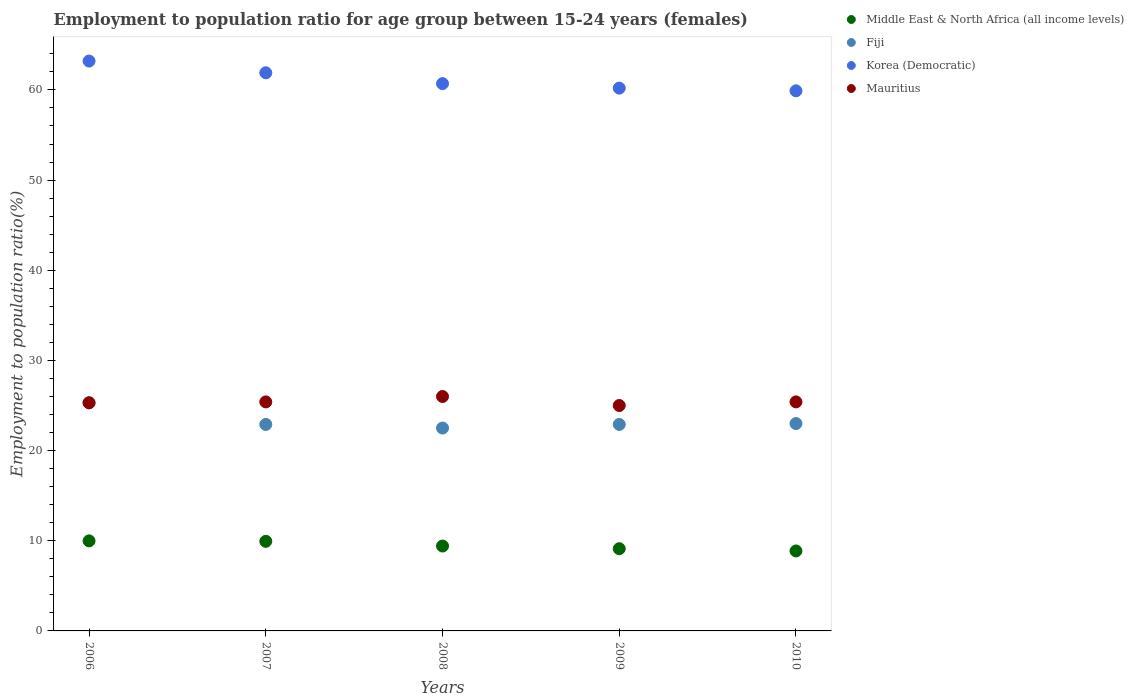How many different coloured dotlines are there?
Provide a succinct answer. 4. What is the employment to population ratio in Korea (Democratic) in 2009?
Provide a short and direct response. 60.2. Across all years, what is the maximum employment to population ratio in Middle East & North Africa (all income levels)?
Offer a terse response. 9.99. Across all years, what is the minimum employment to population ratio in Middle East & North Africa (all income levels)?
Keep it short and to the point. 8.87. In which year was the employment to population ratio in Mauritius maximum?
Your answer should be very brief. 2008. In which year was the employment to population ratio in Fiji minimum?
Provide a short and direct response. 2008. What is the total employment to population ratio in Fiji in the graph?
Keep it short and to the point. 116.6. What is the difference between the employment to population ratio in Mauritius in 2007 and that in 2008?
Ensure brevity in your answer.  -0.6. What is the difference between the employment to population ratio in Fiji in 2006 and the employment to population ratio in Mauritius in 2009?
Make the answer very short. 0.3. What is the average employment to population ratio in Korea (Democratic) per year?
Your answer should be very brief. 61.18. In the year 2009, what is the difference between the employment to population ratio in Middle East & North Africa (all income levels) and employment to population ratio in Korea (Democratic)?
Offer a terse response. -51.08. In how many years, is the employment to population ratio in Middle East & North Africa (all income levels) greater than 20 %?
Offer a terse response. 0. What is the ratio of the employment to population ratio in Middle East & North Africa (all income levels) in 2006 to that in 2007?
Offer a terse response. 1.01. What is the difference between the highest and the second highest employment to population ratio in Korea (Democratic)?
Keep it short and to the point. 1.3. What is the difference between the highest and the lowest employment to population ratio in Korea (Democratic)?
Your response must be concise. 3.3. Is it the case that in every year, the sum of the employment to population ratio in Mauritius and employment to population ratio in Middle East & North Africa (all income levels)  is greater than the employment to population ratio in Korea (Democratic)?
Offer a terse response. No. How many dotlines are there?
Your answer should be very brief. 4. How many years are there in the graph?
Offer a very short reply. 5. Does the graph contain any zero values?
Your answer should be very brief. No. Does the graph contain grids?
Provide a succinct answer. No. How many legend labels are there?
Offer a very short reply. 4. How are the legend labels stacked?
Provide a short and direct response. Vertical. What is the title of the graph?
Ensure brevity in your answer.  Employment to population ratio for age group between 15-24 years (females). Does "Zimbabwe" appear as one of the legend labels in the graph?
Provide a succinct answer. No. What is the label or title of the X-axis?
Your response must be concise. Years. What is the label or title of the Y-axis?
Make the answer very short. Employment to population ratio(%). What is the Employment to population ratio(%) in Middle East & North Africa (all income levels) in 2006?
Provide a short and direct response. 9.99. What is the Employment to population ratio(%) of Fiji in 2006?
Provide a succinct answer. 25.3. What is the Employment to population ratio(%) of Korea (Democratic) in 2006?
Provide a short and direct response. 63.2. What is the Employment to population ratio(%) in Mauritius in 2006?
Your response must be concise. 25.3. What is the Employment to population ratio(%) in Middle East & North Africa (all income levels) in 2007?
Keep it short and to the point. 9.94. What is the Employment to population ratio(%) in Fiji in 2007?
Your answer should be very brief. 22.9. What is the Employment to population ratio(%) of Korea (Democratic) in 2007?
Your answer should be compact. 61.9. What is the Employment to population ratio(%) of Mauritius in 2007?
Give a very brief answer. 25.4. What is the Employment to population ratio(%) of Middle East & North Africa (all income levels) in 2008?
Make the answer very short. 9.41. What is the Employment to population ratio(%) of Korea (Democratic) in 2008?
Keep it short and to the point. 60.7. What is the Employment to population ratio(%) of Mauritius in 2008?
Provide a succinct answer. 26. What is the Employment to population ratio(%) in Middle East & North Africa (all income levels) in 2009?
Make the answer very short. 9.12. What is the Employment to population ratio(%) in Fiji in 2009?
Your answer should be very brief. 22.9. What is the Employment to population ratio(%) of Korea (Democratic) in 2009?
Provide a short and direct response. 60.2. What is the Employment to population ratio(%) in Middle East & North Africa (all income levels) in 2010?
Make the answer very short. 8.87. What is the Employment to population ratio(%) in Fiji in 2010?
Give a very brief answer. 23. What is the Employment to population ratio(%) in Korea (Democratic) in 2010?
Your response must be concise. 59.9. What is the Employment to population ratio(%) in Mauritius in 2010?
Your response must be concise. 25.4. Across all years, what is the maximum Employment to population ratio(%) of Middle East & North Africa (all income levels)?
Give a very brief answer. 9.99. Across all years, what is the maximum Employment to population ratio(%) of Fiji?
Your answer should be compact. 25.3. Across all years, what is the maximum Employment to population ratio(%) of Korea (Democratic)?
Keep it short and to the point. 63.2. Across all years, what is the minimum Employment to population ratio(%) of Middle East & North Africa (all income levels)?
Offer a very short reply. 8.87. Across all years, what is the minimum Employment to population ratio(%) in Korea (Democratic)?
Make the answer very short. 59.9. Across all years, what is the minimum Employment to population ratio(%) of Mauritius?
Ensure brevity in your answer.  25. What is the total Employment to population ratio(%) of Middle East & North Africa (all income levels) in the graph?
Your response must be concise. 47.33. What is the total Employment to population ratio(%) of Fiji in the graph?
Provide a succinct answer. 116.6. What is the total Employment to population ratio(%) in Korea (Democratic) in the graph?
Provide a succinct answer. 305.9. What is the total Employment to population ratio(%) of Mauritius in the graph?
Offer a terse response. 127.1. What is the difference between the Employment to population ratio(%) in Middle East & North Africa (all income levels) in 2006 and that in 2007?
Provide a succinct answer. 0.05. What is the difference between the Employment to population ratio(%) of Middle East & North Africa (all income levels) in 2006 and that in 2008?
Your answer should be very brief. 0.57. What is the difference between the Employment to population ratio(%) of Fiji in 2006 and that in 2008?
Keep it short and to the point. 2.8. What is the difference between the Employment to population ratio(%) in Korea (Democratic) in 2006 and that in 2008?
Provide a short and direct response. 2.5. What is the difference between the Employment to population ratio(%) in Middle East & North Africa (all income levels) in 2006 and that in 2009?
Keep it short and to the point. 0.87. What is the difference between the Employment to population ratio(%) of Middle East & North Africa (all income levels) in 2006 and that in 2010?
Keep it short and to the point. 1.12. What is the difference between the Employment to population ratio(%) of Mauritius in 2006 and that in 2010?
Your answer should be compact. -0.1. What is the difference between the Employment to population ratio(%) in Middle East & North Africa (all income levels) in 2007 and that in 2008?
Provide a short and direct response. 0.52. What is the difference between the Employment to population ratio(%) of Mauritius in 2007 and that in 2008?
Provide a succinct answer. -0.6. What is the difference between the Employment to population ratio(%) of Middle East & North Africa (all income levels) in 2007 and that in 2009?
Your answer should be very brief. 0.82. What is the difference between the Employment to population ratio(%) of Fiji in 2007 and that in 2009?
Provide a short and direct response. 0. What is the difference between the Employment to population ratio(%) in Mauritius in 2007 and that in 2009?
Provide a short and direct response. 0.4. What is the difference between the Employment to population ratio(%) in Middle East & North Africa (all income levels) in 2007 and that in 2010?
Keep it short and to the point. 1.07. What is the difference between the Employment to population ratio(%) of Mauritius in 2007 and that in 2010?
Keep it short and to the point. 0. What is the difference between the Employment to population ratio(%) in Middle East & North Africa (all income levels) in 2008 and that in 2009?
Your answer should be very brief. 0.29. What is the difference between the Employment to population ratio(%) in Fiji in 2008 and that in 2009?
Make the answer very short. -0.4. What is the difference between the Employment to population ratio(%) in Korea (Democratic) in 2008 and that in 2009?
Keep it short and to the point. 0.5. What is the difference between the Employment to population ratio(%) of Mauritius in 2008 and that in 2009?
Your response must be concise. 1. What is the difference between the Employment to population ratio(%) in Middle East & North Africa (all income levels) in 2008 and that in 2010?
Ensure brevity in your answer.  0.55. What is the difference between the Employment to population ratio(%) of Fiji in 2008 and that in 2010?
Offer a very short reply. -0.5. What is the difference between the Employment to population ratio(%) in Mauritius in 2008 and that in 2010?
Provide a short and direct response. 0.6. What is the difference between the Employment to population ratio(%) in Middle East & North Africa (all income levels) in 2009 and that in 2010?
Your answer should be compact. 0.25. What is the difference between the Employment to population ratio(%) of Korea (Democratic) in 2009 and that in 2010?
Provide a short and direct response. 0.3. What is the difference between the Employment to population ratio(%) in Middle East & North Africa (all income levels) in 2006 and the Employment to population ratio(%) in Fiji in 2007?
Provide a short and direct response. -12.91. What is the difference between the Employment to population ratio(%) of Middle East & North Africa (all income levels) in 2006 and the Employment to population ratio(%) of Korea (Democratic) in 2007?
Ensure brevity in your answer.  -51.91. What is the difference between the Employment to population ratio(%) of Middle East & North Africa (all income levels) in 2006 and the Employment to population ratio(%) of Mauritius in 2007?
Provide a succinct answer. -15.41. What is the difference between the Employment to population ratio(%) of Fiji in 2006 and the Employment to population ratio(%) of Korea (Democratic) in 2007?
Make the answer very short. -36.6. What is the difference between the Employment to population ratio(%) in Korea (Democratic) in 2006 and the Employment to population ratio(%) in Mauritius in 2007?
Give a very brief answer. 37.8. What is the difference between the Employment to population ratio(%) in Middle East & North Africa (all income levels) in 2006 and the Employment to population ratio(%) in Fiji in 2008?
Offer a terse response. -12.51. What is the difference between the Employment to population ratio(%) of Middle East & North Africa (all income levels) in 2006 and the Employment to population ratio(%) of Korea (Democratic) in 2008?
Your answer should be very brief. -50.71. What is the difference between the Employment to population ratio(%) in Middle East & North Africa (all income levels) in 2006 and the Employment to population ratio(%) in Mauritius in 2008?
Ensure brevity in your answer.  -16.01. What is the difference between the Employment to population ratio(%) in Fiji in 2006 and the Employment to population ratio(%) in Korea (Democratic) in 2008?
Make the answer very short. -35.4. What is the difference between the Employment to population ratio(%) of Fiji in 2006 and the Employment to population ratio(%) of Mauritius in 2008?
Provide a short and direct response. -0.7. What is the difference between the Employment to population ratio(%) of Korea (Democratic) in 2006 and the Employment to population ratio(%) of Mauritius in 2008?
Your answer should be very brief. 37.2. What is the difference between the Employment to population ratio(%) of Middle East & North Africa (all income levels) in 2006 and the Employment to population ratio(%) of Fiji in 2009?
Offer a very short reply. -12.91. What is the difference between the Employment to population ratio(%) of Middle East & North Africa (all income levels) in 2006 and the Employment to population ratio(%) of Korea (Democratic) in 2009?
Your response must be concise. -50.21. What is the difference between the Employment to population ratio(%) of Middle East & North Africa (all income levels) in 2006 and the Employment to population ratio(%) of Mauritius in 2009?
Give a very brief answer. -15.01. What is the difference between the Employment to population ratio(%) in Fiji in 2006 and the Employment to population ratio(%) in Korea (Democratic) in 2009?
Provide a succinct answer. -34.9. What is the difference between the Employment to population ratio(%) of Fiji in 2006 and the Employment to population ratio(%) of Mauritius in 2009?
Give a very brief answer. 0.3. What is the difference between the Employment to population ratio(%) of Korea (Democratic) in 2006 and the Employment to population ratio(%) of Mauritius in 2009?
Provide a short and direct response. 38.2. What is the difference between the Employment to population ratio(%) in Middle East & North Africa (all income levels) in 2006 and the Employment to population ratio(%) in Fiji in 2010?
Ensure brevity in your answer.  -13.01. What is the difference between the Employment to population ratio(%) in Middle East & North Africa (all income levels) in 2006 and the Employment to population ratio(%) in Korea (Democratic) in 2010?
Ensure brevity in your answer.  -49.91. What is the difference between the Employment to population ratio(%) in Middle East & North Africa (all income levels) in 2006 and the Employment to population ratio(%) in Mauritius in 2010?
Your response must be concise. -15.41. What is the difference between the Employment to population ratio(%) in Fiji in 2006 and the Employment to population ratio(%) in Korea (Democratic) in 2010?
Give a very brief answer. -34.6. What is the difference between the Employment to population ratio(%) of Fiji in 2006 and the Employment to population ratio(%) of Mauritius in 2010?
Provide a succinct answer. -0.1. What is the difference between the Employment to population ratio(%) of Korea (Democratic) in 2006 and the Employment to population ratio(%) of Mauritius in 2010?
Keep it short and to the point. 37.8. What is the difference between the Employment to population ratio(%) in Middle East & North Africa (all income levels) in 2007 and the Employment to population ratio(%) in Fiji in 2008?
Your response must be concise. -12.56. What is the difference between the Employment to population ratio(%) of Middle East & North Africa (all income levels) in 2007 and the Employment to population ratio(%) of Korea (Democratic) in 2008?
Your response must be concise. -50.76. What is the difference between the Employment to population ratio(%) of Middle East & North Africa (all income levels) in 2007 and the Employment to population ratio(%) of Mauritius in 2008?
Your answer should be very brief. -16.06. What is the difference between the Employment to population ratio(%) in Fiji in 2007 and the Employment to population ratio(%) in Korea (Democratic) in 2008?
Your answer should be very brief. -37.8. What is the difference between the Employment to population ratio(%) of Fiji in 2007 and the Employment to population ratio(%) of Mauritius in 2008?
Your response must be concise. -3.1. What is the difference between the Employment to population ratio(%) in Korea (Democratic) in 2007 and the Employment to population ratio(%) in Mauritius in 2008?
Offer a terse response. 35.9. What is the difference between the Employment to population ratio(%) of Middle East & North Africa (all income levels) in 2007 and the Employment to population ratio(%) of Fiji in 2009?
Give a very brief answer. -12.96. What is the difference between the Employment to population ratio(%) of Middle East & North Africa (all income levels) in 2007 and the Employment to population ratio(%) of Korea (Democratic) in 2009?
Offer a terse response. -50.26. What is the difference between the Employment to population ratio(%) in Middle East & North Africa (all income levels) in 2007 and the Employment to population ratio(%) in Mauritius in 2009?
Your response must be concise. -15.06. What is the difference between the Employment to population ratio(%) of Fiji in 2007 and the Employment to population ratio(%) of Korea (Democratic) in 2009?
Provide a short and direct response. -37.3. What is the difference between the Employment to population ratio(%) in Fiji in 2007 and the Employment to population ratio(%) in Mauritius in 2009?
Ensure brevity in your answer.  -2.1. What is the difference between the Employment to population ratio(%) of Korea (Democratic) in 2007 and the Employment to population ratio(%) of Mauritius in 2009?
Make the answer very short. 36.9. What is the difference between the Employment to population ratio(%) of Middle East & North Africa (all income levels) in 2007 and the Employment to population ratio(%) of Fiji in 2010?
Give a very brief answer. -13.06. What is the difference between the Employment to population ratio(%) of Middle East & North Africa (all income levels) in 2007 and the Employment to population ratio(%) of Korea (Democratic) in 2010?
Give a very brief answer. -49.96. What is the difference between the Employment to population ratio(%) in Middle East & North Africa (all income levels) in 2007 and the Employment to population ratio(%) in Mauritius in 2010?
Provide a short and direct response. -15.46. What is the difference between the Employment to population ratio(%) of Fiji in 2007 and the Employment to population ratio(%) of Korea (Democratic) in 2010?
Your answer should be very brief. -37. What is the difference between the Employment to population ratio(%) in Fiji in 2007 and the Employment to population ratio(%) in Mauritius in 2010?
Give a very brief answer. -2.5. What is the difference between the Employment to population ratio(%) of Korea (Democratic) in 2007 and the Employment to population ratio(%) of Mauritius in 2010?
Keep it short and to the point. 36.5. What is the difference between the Employment to population ratio(%) in Middle East & North Africa (all income levels) in 2008 and the Employment to population ratio(%) in Fiji in 2009?
Provide a succinct answer. -13.49. What is the difference between the Employment to population ratio(%) in Middle East & North Africa (all income levels) in 2008 and the Employment to population ratio(%) in Korea (Democratic) in 2009?
Your answer should be compact. -50.79. What is the difference between the Employment to population ratio(%) of Middle East & North Africa (all income levels) in 2008 and the Employment to population ratio(%) of Mauritius in 2009?
Ensure brevity in your answer.  -15.59. What is the difference between the Employment to population ratio(%) in Fiji in 2008 and the Employment to population ratio(%) in Korea (Democratic) in 2009?
Make the answer very short. -37.7. What is the difference between the Employment to population ratio(%) in Korea (Democratic) in 2008 and the Employment to population ratio(%) in Mauritius in 2009?
Offer a terse response. 35.7. What is the difference between the Employment to population ratio(%) in Middle East & North Africa (all income levels) in 2008 and the Employment to population ratio(%) in Fiji in 2010?
Your response must be concise. -13.59. What is the difference between the Employment to population ratio(%) of Middle East & North Africa (all income levels) in 2008 and the Employment to population ratio(%) of Korea (Democratic) in 2010?
Offer a very short reply. -50.49. What is the difference between the Employment to population ratio(%) of Middle East & North Africa (all income levels) in 2008 and the Employment to population ratio(%) of Mauritius in 2010?
Offer a terse response. -15.99. What is the difference between the Employment to population ratio(%) of Fiji in 2008 and the Employment to population ratio(%) of Korea (Democratic) in 2010?
Make the answer very short. -37.4. What is the difference between the Employment to population ratio(%) of Korea (Democratic) in 2008 and the Employment to population ratio(%) of Mauritius in 2010?
Make the answer very short. 35.3. What is the difference between the Employment to population ratio(%) of Middle East & North Africa (all income levels) in 2009 and the Employment to population ratio(%) of Fiji in 2010?
Ensure brevity in your answer.  -13.88. What is the difference between the Employment to population ratio(%) in Middle East & North Africa (all income levels) in 2009 and the Employment to population ratio(%) in Korea (Democratic) in 2010?
Offer a terse response. -50.78. What is the difference between the Employment to population ratio(%) in Middle East & North Africa (all income levels) in 2009 and the Employment to population ratio(%) in Mauritius in 2010?
Provide a succinct answer. -16.28. What is the difference between the Employment to population ratio(%) of Fiji in 2009 and the Employment to population ratio(%) of Korea (Democratic) in 2010?
Your answer should be compact. -37. What is the difference between the Employment to population ratio(%) in Korea (Democratic) in 2009 and the Employment to population ratio(%) in Mauritius in 2010?
Keep it short and to the point. 34.8. What is the average Employment to population ratio(%) in Middle East & North Africa (all income levels) per year?
Your response must be concise. 9.47. What is the average Employment to population ratio(%) in Fiji per year?
Your response must be concise. 23.32. What is the average Employment to population ratio(%) of Korea (Democratic) per year?
Your answer should be very brief. 61.18. What is the average Employment to population ratio(%) in Mauritius per year?
Provide a short and direct response. 25.42. In the year 2006, what is the difference between the Employment to population ratio(%) in Middle East & North Africa (all income levels) and Employment to population ratio(%) in Fiji?
Your answer should be compact. -15.31. In the year 2006, what is the difference between the Employment to population ratio(%) in Middle East & North Africa (all income levels) and Employment to population ratio(%) in Korea (Democratic)?
Offer a very short reply. -53.21. In the year 2006, what is the difference between the Employment to population ratio(%) of Middle East & North Africa (all income levels) and Employment to population ratio(%) of Mauritius?
Make the answer very short. -15.31. In the year 2006, what is the difference between the Employment to population ratio(%) in Fiji and Employment to population ratio(%) in Korea (Democratic)?
Give a very brief answer. -37.9. In the year 2006, what is the difference between the Employment to population ratio(%) of Fiji and Employment to population ratio(%) of Mauritius?
Your answer should be very brief. 0. In the year 2006, what is the difference between the Employment to population ratio(%) of Korea (Democratic) and Employment to population ratio(%) of Mauritius?
Ensure brevity in your answer.  37.9. In the year 2007, what is the difference between the Employment to population ratio(%) of Middle East & North Africa (all income levels) and Employment to population ratio(%) of Fiji?
Give a very brief answer. -12.96. In the year 2007, what is the difference between the Employment to population ratio(%) in Middle East & North Africa (all income levels) and Employment to population ratio(%) in Korea (Democratic)?
Give a very brief answer. -51.96. In the year 2007, what is the difference between the Employment to population ratio(%) in Middle East & North Africa (all income levels) and Employment to population ratio(%) in Mauritius?
Provide a short and direct response. -15.46. In the year 2007, what is the difference between the Employment to population ratio(%) of Fiji and Employment to population ratio(%) of Korea (Democratic)?
Offer a terse response. -39. In the year 2007, what is the difference between the Employment to population ratio(%) of Korea (Democratic) and Employment to population ratio(%) of Mauritius?
Offer a very short reply. 36.5. In the year 2008, what is the difference between the Employment to population ratio(%) of Middle East & North Africa (all income levels) and Employment to population ratio(%) of Fiji?
Make the answer very short. -13.09. In the year 2008, what is the difference between the Employment to population ratio(%) of Middle East & North Africa (all income levels) and Employment to population ratio(%) of Korea (Democratic)?
Keep it short and to the point. -51.29. In the year 2008, what is the difference between the Employment to population ratio(%) of Middle East & North Africa (all income levels) and Employment to population ratio(%) of Mauritius?
Offer a very short reply. -16.59. In the year 2008, what is the difference between the Employment to population ratio(%) in Fiji and Employment to population ratio(%) in Korea (Democratic)?
Provide a short and direct response. -38.2. In the year 2008, what is the difference between the Employment to population ratio(%) in Fiji and Employment to population ratio(%) in Mauritius?
Your answer should be very brief. -3.5. In the year 2008, what is the difference between the Employment to population ratio(%) in Korea (Democratic) and Employment to population ratio(%) in Mauritius?
Your answer should be very brief. 34.7. In the year 2009, what is the difference between the Employment to population ratio(%) in Middle East & North Africa (all income levels) and Employment to population ratio(%) in Fiji?
Provide a succinct answer. -13.78. In the year 2009, what is the difference between the Employment to population ratio(%) of Middle East & North Africa (all income levels) and Employment to population ratio(%) of Korea (Democratic)?
Ensure brevity in your answer.  -51.08. In the year 2009, what is the difference between the Employment to population ratio(%) in Middle East & North Africa (all income levels) and Employment to population ratio(%) in Mauritius?
Your response must be concise. -15.88. In the year 2009, what is the difference between the Employment to population ratio(%) of Fiji and Employment to population ratio(%) of Korea (Democratic)?
Provide a succinct answer. -37.3. In the year 2009, what is the difference between the Employment to population ratio(%) in Korea (Democratic) and Employment to population ratio(%) in Mauritius?
Keep it short and to the point. 35.2. In the year 2010, what is the difference between the Employment to population ratio(%) in Middle East & North Africa (all income levels) and Employment to population ratio(%) in Fiji?
Ensure brevity in your answer.  -14.13. In the year 2010, what is the difference between the Employment to population ratio(%) of Middle East & North Africa (all income levels) and Employment to population ratio(%) of Korea (Democratic)?
Your answer should be compact. -51.03. In the year 2010, what is the difference between the Employment to population ratio(%) of Middle East & North Africa (all income levels) and Employment to population ratio(%) of Mauritius?
Provide a short and direct response. -16.53. In the year 2010, what is the difference between the Employment to population ratio(%) in Fiji and Employment to population ratio(%) in Korea (Democratic)?
Your answer should be compact. -36.9. In the year 2010, what is the difference between the Employment to population ratio(%) in Korea (Democratic) and Employment to population ratio(%) in Mauritius?
Offer a terse response. 34.5. What is the ratio of the Employment to population ratio(%) of Fiji in 2006 to that in 2007?
Offer a terse response. 1.1. What is the ratio of the Employment to population ratio(%) of Mauritius in 2006 to that in 2007?
Ensure brevity in your answer.  1. What is the ratio of the Employment to population ratio(%) in Middle East & North Africa (all income levels) in 2006 to that in 2008?
Provide a succinct answer. 1.06. What is the ratio of the Employment to population ratio(%) in Fiji in 2006 to that in 2008?
Ensure brevity in your answer.  1.12. What is the ratio of the Employment to population ratio(%) in Korea (Democratic) in 2006 to that in 2008?
Offer a very short reply. 1.04. What is the ratio of the Employment to population ratio(%) of Mauritius in 2006 to that in 2008?
Offer a terse response. 0.97. What is the ratio of the Employment to population ratio(%) in Middle East & North Africa (all income levels) in 2006 to that in 2009?
Offer a terse response. 1.1. What is the ratio of the Employment to population ratio(%) in Fiji in 2006 to that in 2009?
Ensure brevity in your answer.  1.1. What is the ratio of the Employment to population ratio(%) in Korea (Democratic) in 2006 to that in 2009?
Your response must be concise. 1.05. What is the ratio of the Employment to population ratio(%) of Middle East & North Africa (all income levels) in 2006 to that in 2010?
Provide a succinct answer. 1.13. What is the ratio of the Employment to population ratio(%) in Fiji in 2006 to that in 2010?
Offer a terse response. 1.1. What is the ratio of the Employment to population ratio(%) of Korea (Democratic) in 2006 to that in 2010?
Make the answer very short. 1.06. What is the ratio of the Employment to population ratio(%) in Mauritius in 2006 to that in 2010?
Your answer should be compact. 1. What is the ratio of the Employment to population ratio(%) in Middle East & North Africa (all income levels) in 2007 to that in 2008?
Provide a succinct answer. 1.06. What is the ratio of the Employment to population ratio(%) in Fiji in 2007 to that in 2008?
Give a very brief answer. 1.02. What is the ratio of the Employment to population ratio(%) in Korea (Democratic) in 2007 to that in 2008?
Offer a terse response. 1.02. What is the ratio of the Employment to population ratio(%) in Mauritius in 2007 to that in 2008?
Provide a succinct answer. 0.98. What is the ratio of the Employment to population ratio(%) in Middle East & North Africa (all income levels) in 2007 to that in 2009?
Keep it short and to the point. 1.09. What is the ratio of the Employment to population ratio(%) in Korea (Democratic) in 2007 to that in 2009?
Offer a terse response. 1.03. What is the ratio of the Employment to population ratio(%) of Middle East & North Africa (all income levels) in 2007 to that in 2010?
Your answer should be very brief. 1.12. What is the ratio of the Employment to population ratio(%) of Korea (Democratic) in 2007 to that in 2010?
Your answer should be compact. 1.03. What is the ratio of the Employment to population ratio(%) of Mauritius in 2007 to that in 2010?
Keep it short and to the point. 1. What is the ratio of the Employment to population ratio(%) in Middle East & North Africa (all income levels) in 2008 to that in 2009?
Provide a succinct answer. 1.03. What is the ratio of the Employment to population ratio(%) of Fiji in 2008 to that in 2009?
Offer a very short reply. 0.98. What is the ratio of the Employment to population ratio(%) of Korea (Democratic) in 2008 to that in 2009?
Your answer should be compact. 1.01. What is the ratio of the Employment to population ratio(%) in Mauritius in 2008 to that in 2009?
Provide a succinct answer. 1.04. What is the ratio of the Employment to population ratio(%) of Middle East & North Africa (all income levels) in 2008 to that in 2010?
Offer a very short reply. 1.06. What is the ratio of the Employment to population ratio(%) in Fiji in 2008 to that in 2010?
Your response must be concise. 0.98. What is the ratio of the Employment to population ratio(%) of Korea (Democratic) in 2008 to that in 2010?
Your answer should be compact. 1.01. What is the ratio of the Employment to population ratio(%) in Mauritius in 2008 to that in 2010?
Ensure brevity in your answer.  1.02. What is the ratio of the Employment to population ratio(%) in Middle East & North Africa (all income levels) in 2009 to that in 2010?
Provide a short and direct response. 1.03. What is the ratio of the Employment to population ratio(%) in Korea (Democratic) in 2009 to that in 2010?
Provide a succinct answer. 1. What is the ratio of the Employment to population ratio(%) of Mauritius in 2009 to that in 2010?
Your answer should be very brief. 0.98. What is the difference between the highest and the second highest Employment to population ratio(%) of Middle East & North Africa (all income levels)?
Provide a short and direct response. 0.05. What is the difference between the highest and the second highest Employment to population ratio(%) of Mauritius?
Ensure brevity in your answer.  0.6. What is the difference between the highest and the lowest Employment to population ratio(%) in Middle East & North Africa (all income levels)?
Provide a succinct answer. 1.12. 